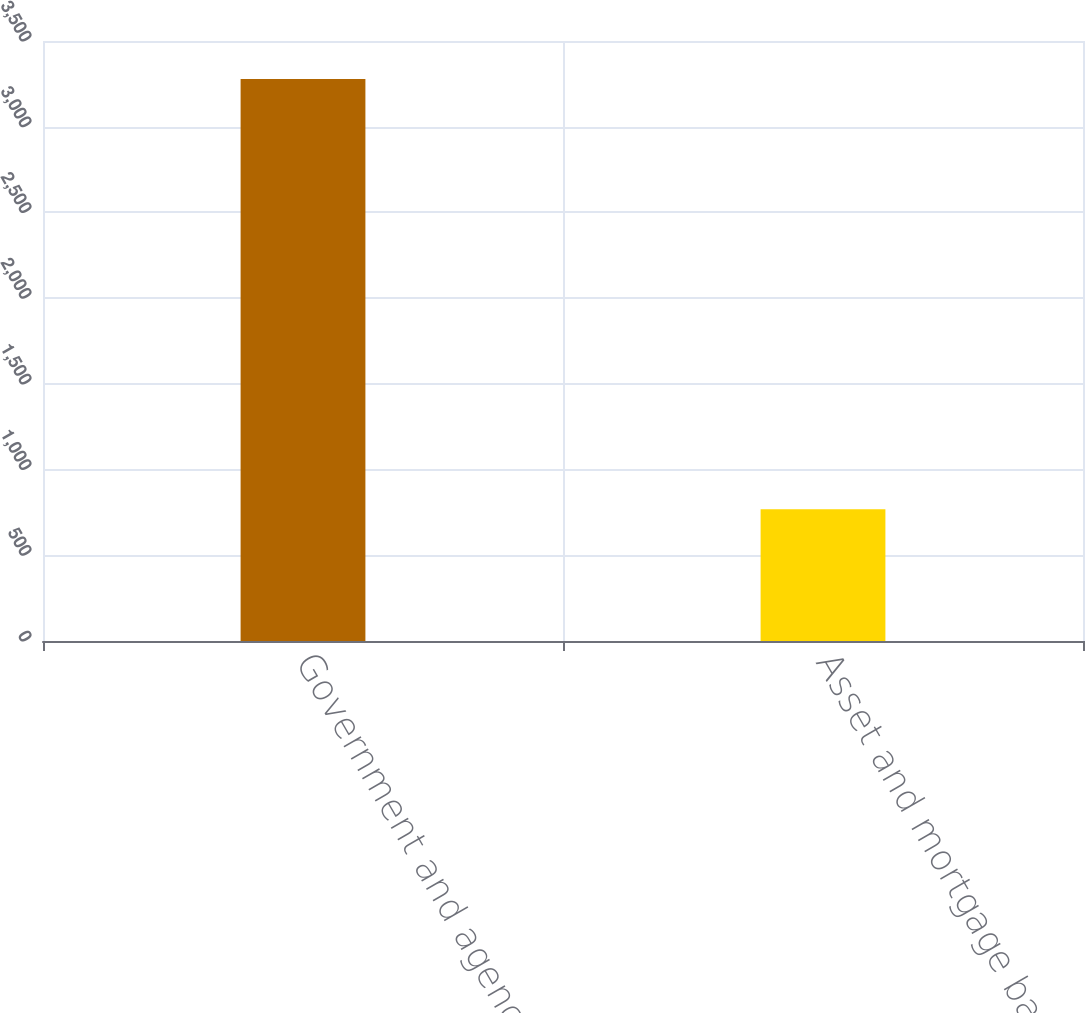Convert chart. <chart><loc_0><loc_0><loc_500><loc_500><bar_chart><fcel>Government and agency<fcel>Asset and mortgage backed<nl><fcel>3279<fcel>768<nl></chart> 